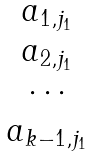Convert formula to latex. <formula><loc_0><loc_0><loc_500><loc_500>\begin{matrix} a _ { 1 , j _ { 1 } } \\ a _ { 2 , j _ { 1 } } \\ \cdots \\ a _ { k - 1 , j _ { 1 } } \end{matrix}</formula> 